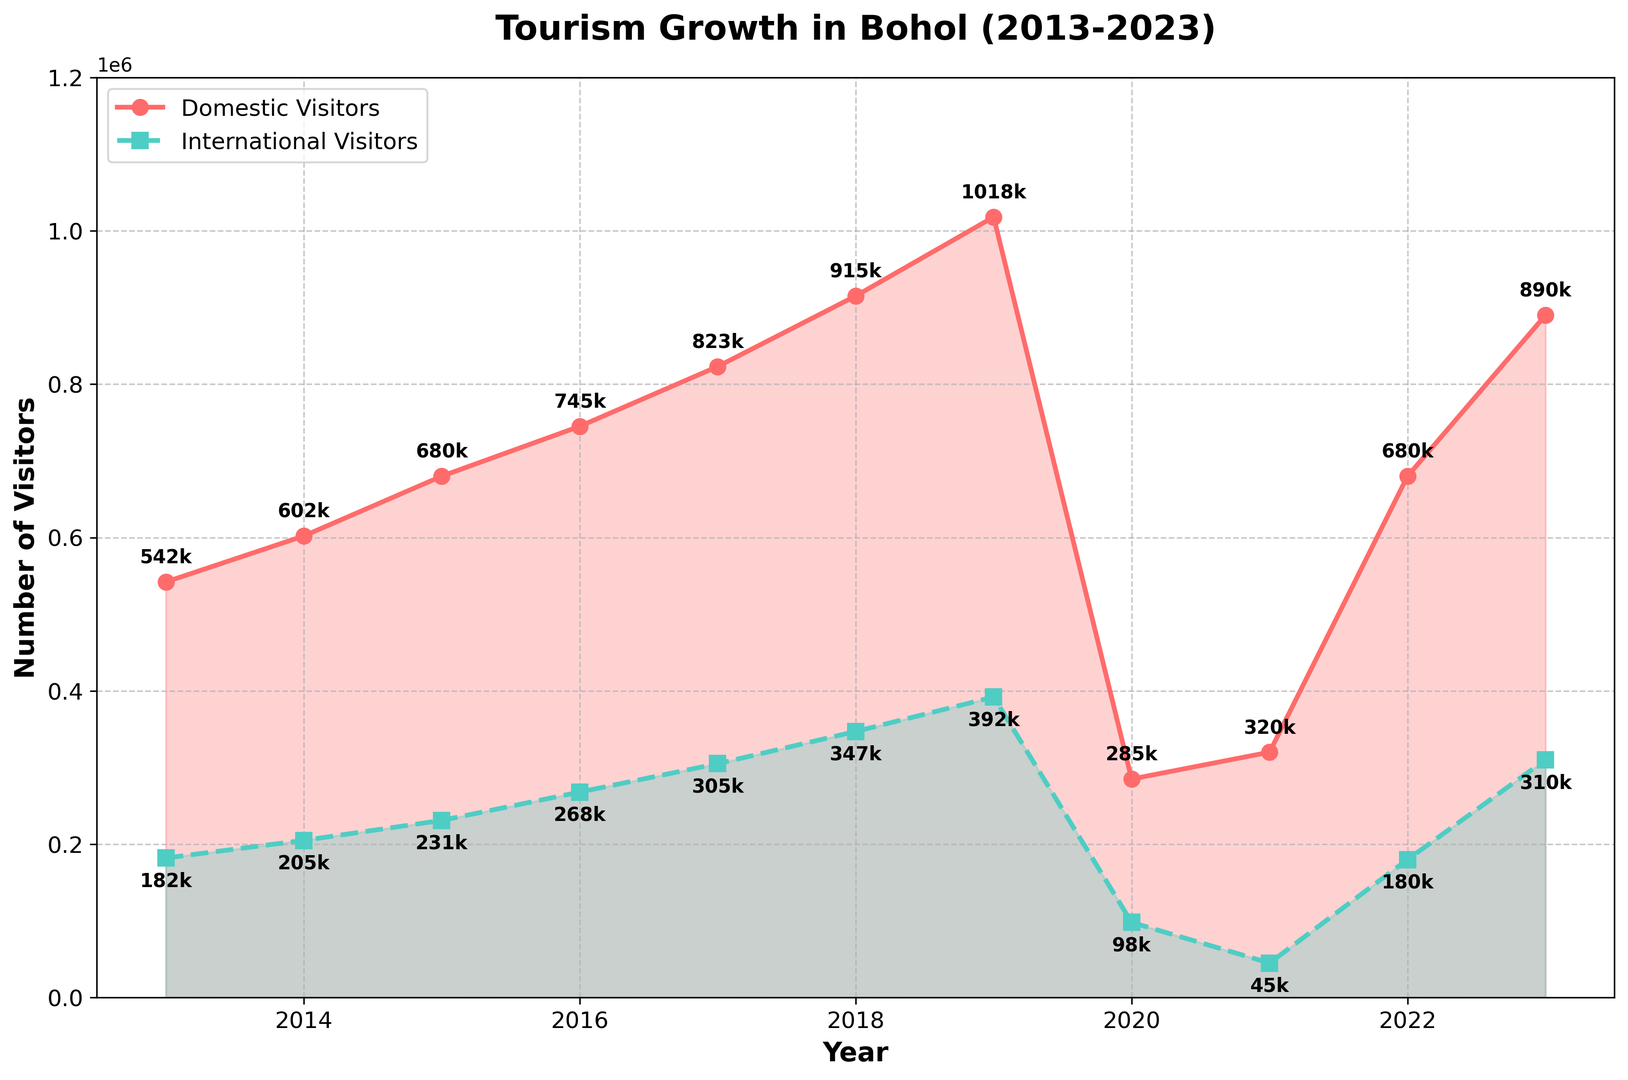What was the number of domestic visitors in 2020? The figure shows that in 2020, the point on the red line for domestic visitors is labeled with 285k, which stands for 285,000 visitors.
Answer: 285,000 In which year did international visitors first exceed 300,000? The green dashed line representing international visitors exceeds the 300,000 mark in 2017, as indicated by the point labeled 305k.
Answer: 2017 What is the highest number of domestic visitors recorded from 2013 to 2023? The domestic visitors' line reaches its highest point in 2019, labeled as 1,018k, which means 1,018,000 visitors.
Answer: 1,018,000 Compare the number of international visitors between 2019 and 2023. Which year had more visitors? In 2019, the number of international visitors is 392k, and in 2023 it is 310k. Comparing these, 2019 had more international visitors.
Answer: 2019 By how much did domestic visitors decrease from 2019 to 2020? The number of domestic visitors in 2019 was 1,018k while in 2020 it was 285k. The decrease is 1,018,000 - 285,000 = 733,000.
Answer: 733,000 What is the average number of international visitors from 2013 to 2023? Summing the international visitors from 2013 to 2023 gives a total of 2,763,000. There are 11 years in the period, so the average is 2,763,000 / 11 ≈ 251,182 visitors.
Answer: 251,182 Which type of visitors, domestic or international, showed a greater percentage increase from 2013 to 2019? For domestic visitors: (1,018,000 - 542,000) / 542,000 ≈ 0.88 or 88%. For international visitors: (392,000 - 182,000) / 182,000 ≈ 1.15 or 115%. International visitors showed a greater percentage increase.
Answer: International Did the number of visitors (domestic + international) ever decrease from one year to the next between 2013 and 2023 other than the decrease in 2020? Only 2021 showed a decrease in total visitors compared to the previous year, as the drop from 285k to 320k for domestic, and 98k to 45k for international occurred.
Answer: Yes What is the percentage of domestic visitors out of total visitors in 2023? In 2023, domestic visitors were 890k and international visitors were 310k. The total visitors were 1,200,000. The percentage is (890,000 / 1,200,000) * 100 ≈ 74.17%.
Answer: 74.17% 